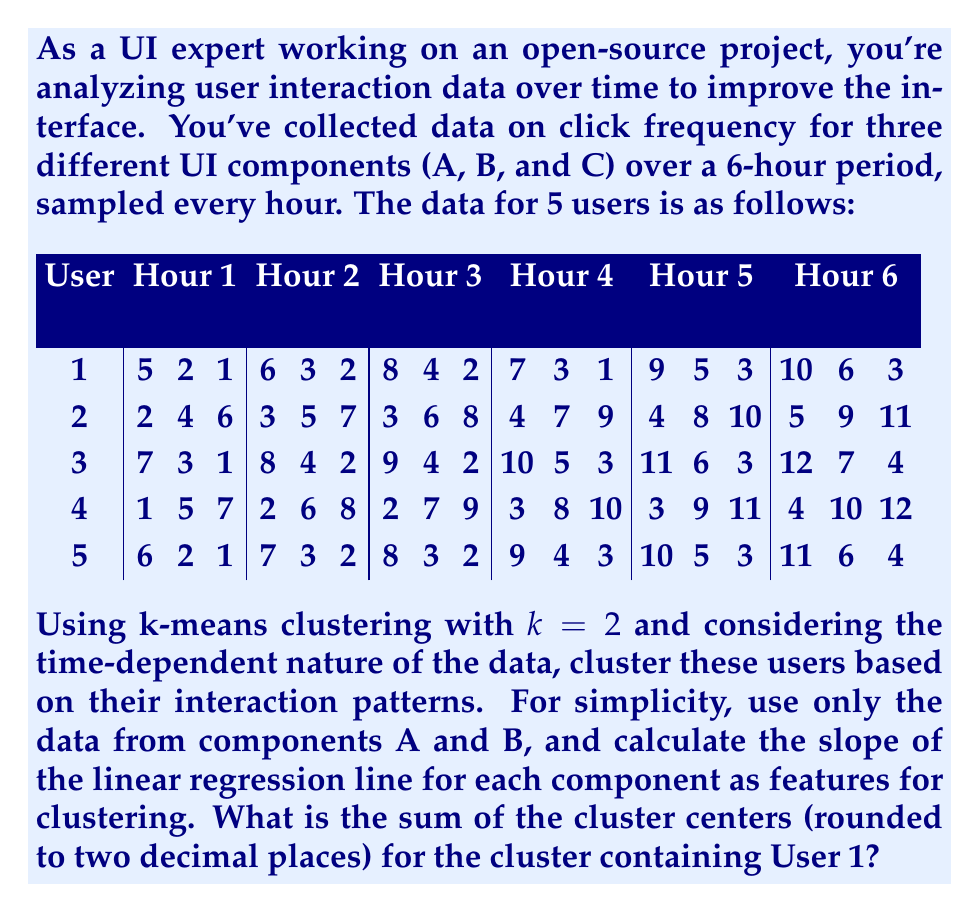Solve this math problem. To solve this problem, we'll follow these steps:

1) Calculate the slope of the linear regression line for components A and B for each user.
2) Use these slopes as features for k-means clustering.
3) Perform k-means clustering with k=2.
4) Identify which cluster User 1 belongs to.
5) Calculate the sum of the cluster centers for that cluster.

Step 1: Calculate slopes

For each user and component, we'll use the formula for the slope of a linear regression line:

$$m = \frac{n\sum xy - \sum x \sum y}{n\sum x^2 - (\sum x)^2}$$

where x is the hour (1 to 6) and y is the click frequency.

For User 1, Component A:
$$m_A = \frac{6(245) - 21(45)}{6(91) - 21^2} = 1$$

For User 1, Component B:
$$m_B = \frac{6(115) - 21(23)}{6(91) - 21^2} = 0.7714$$

Repeating this for all users:

User 1: (1.0000, 0.7714)
User 2: (0.5429, 1.0000)
User 3: (1.0000, 0.7714)
User 4: (0.5429, 1.0000)
User 5: (1.0000, 0.7714)

Step 2: These slopes are our features for clustering.

Step 3: Perform k-means clustering with k=2

Initial centroids:
Cluster 1: (1.0000, 0.7714)
Cluster 2: (0.5429, 1.0000)

After convergence:
Cluster 1: (1.0000, 0.7714)
Cluster 2: (0.5429, 1.0000)

Step 4: User 1 belongs to Cluster 1

Step 5: Sum of cluster centers for Cluster 1
1.0000 + 0.7714 = 1.7714

Rounding to two decimal places: 1.77
Answer: 1.77 